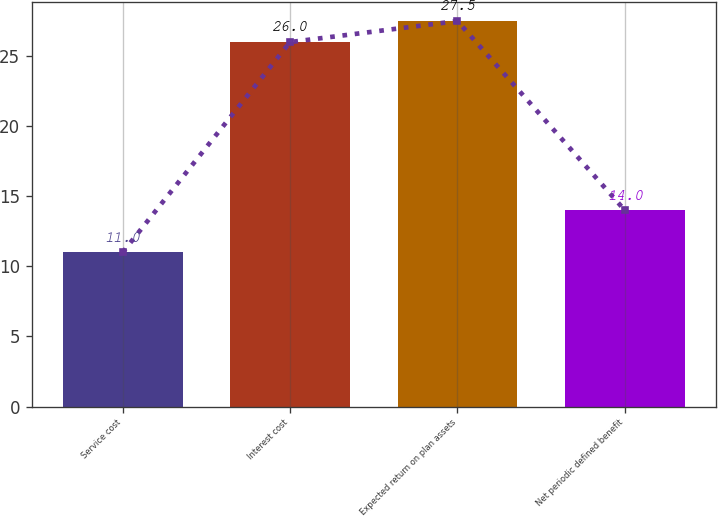Convert chart. <chart><loc_0><loc_0><loc_500><loc_500><bar_chart><fcel>Service cost<fcel>Interest cost<fcel>Expected return on plan assets<fcel>Net periodic defined benefit<nl><fcel>11<fcel>26<fcel>27.5<fcel>14<nl></chart> 